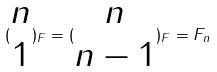Convert formula to latex. <formula><loc_0><loc_0><loc_500><loc_500>( \begin{matrix} n \\ 1 \end{matrix} ) _ { F } = ( \begin{matrix} n \\ n - 1 \end{matrix} ) _ { F } = F _ { n }</formula> 